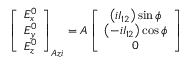<formula> <loc_0><loc_0><loc_500><loc_500>\left [ \begin{array} { c } { E _ { x } ^ { 0 } } \\ { E _ { y } ^ { 0 } } \\ { E _ { z } ^ { 0 } } \end{array} \right ] _ { A z i } = A \left [ \begin{array} { c } { \left ( i I _ { 1 2 } \right ) \sin \phi } \\ { \left ( - i I _ { 1 2 } \right ) \cos \phi } \\ { 0 } \end{array} \right ]</formula> 